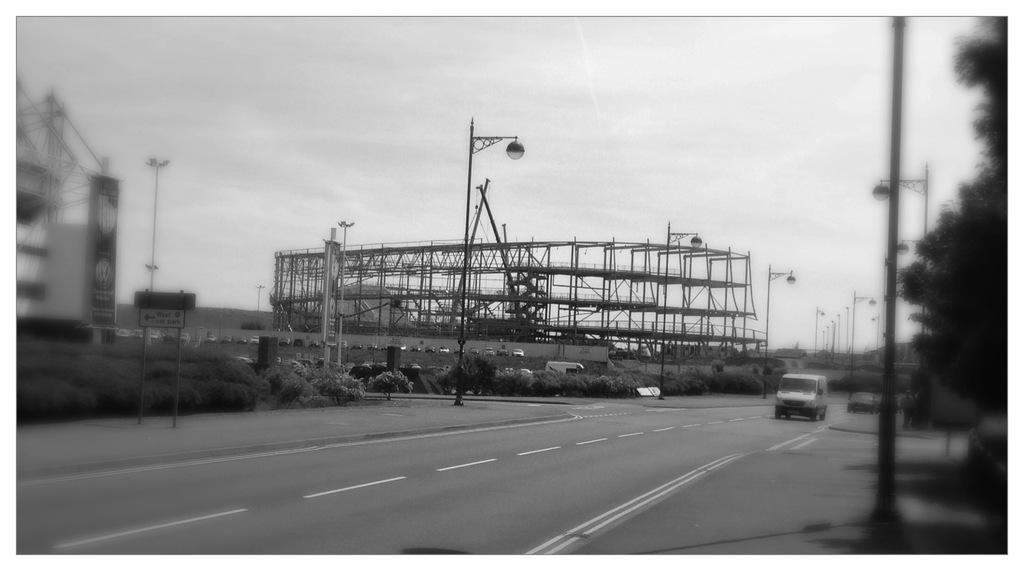Could you give a brief overview of what you see in this image? In this image we can see an under construction building and a building beside of it, there we can see few street lights attached to the poles, a vehicle on the road, few vehicles, few trees and plants and the sky. 